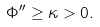Convert formula to latex. <formula><loc_0><loc_0><loc_500><loc_500>\Phi ^ { \prime \prime } \geq \kappa > 0 .</formula> 